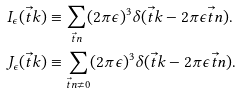<formula> <loc_0><loc_0><loc_500><loc_500>I _ { \epsilon } ( \vec { t } k ) & \equiv \sum _ { \vec { t } n } ( 2 \pi \epsilon ) ^ { 3 } \delta ( \vec { t } k - 2 \pi \epsilon \vec { t } n ) . \\ J _ { \epsilon } ( \vec { t } k ) & \equiv \sum _ { \vec { t } n \neq 0 } ( 2 \pi \epsilon ) ^ { 3 } \delta ( \vec { t } k - 2 \pi \epsilon \vec { t } n ) .</formula> 